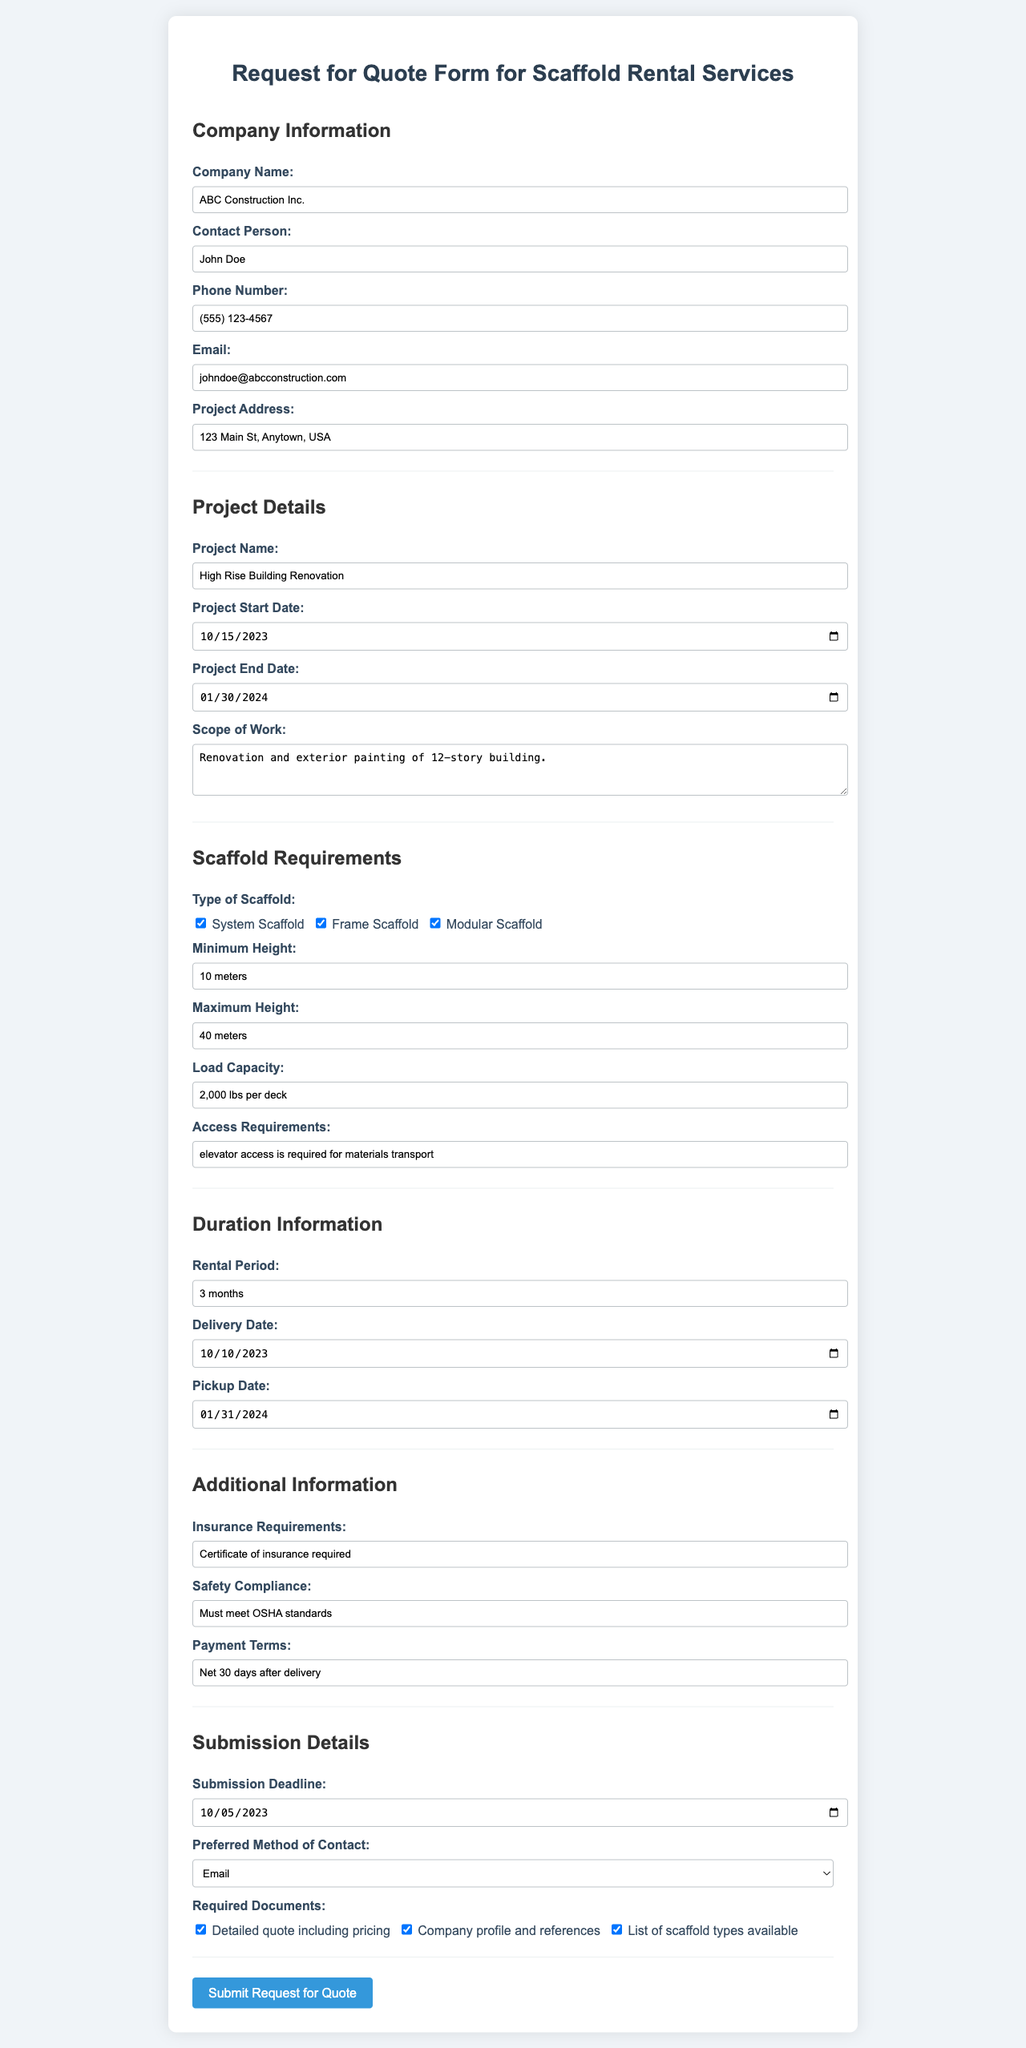what is the company name? The company name is located in the Company Information section of the form.
Answer: ABC Construction Inc who is the contact person? The contact person's name is found under the Company Information section of the form.
Answer: John Doe what is the project address? The project address is specified in the Company Information section of the form.
Answer: 123 Main St, Anytown, USA what is the rental period? The rental period is listed in the Duration Information section of the form.
Answer: 3 months what is the minimum height requirement? The minimum height requirement appears in the Scaffold Requirements section of the form.
Answer: 10 meters what is the load capacity? The load capacity is mentioned in the Scaffold Requirements section of the form.
Answer: 2,000 lbs per deck what insurance documentation is required? The insurance requirements can be found in the Additional Information section of the form.
Answer: Certificate of insurance required when is the submission deadline? The submission deadline is specified in the Submission Details section of the form.
Answer: 2023-10-05 which method of contact is preferred? The preferred method of contact is selected in the Submission Details section of the form.
Answer: Email 